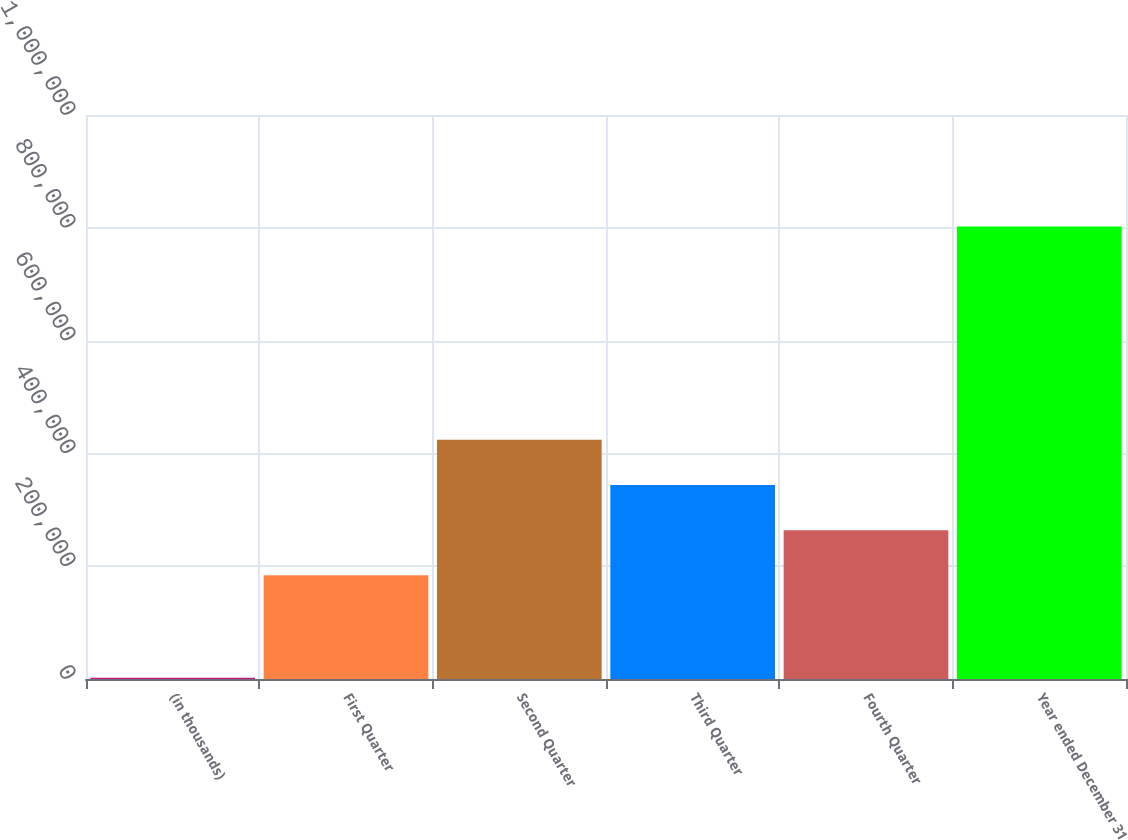<chart> <loc_0><loc_0><loc_500><loc_500><bar_chart><fcel>(in thousands)<fcel>First Quarter<fcel>Second Quarter<fcel>Third Quarter<fcel>Fourth Quarter<fcel>Year ended December 31<nl><fcel>2005<fcel>183915<fcel>424039<fcel>343997<fcel>263956<fcel>802417<nl></chart> 